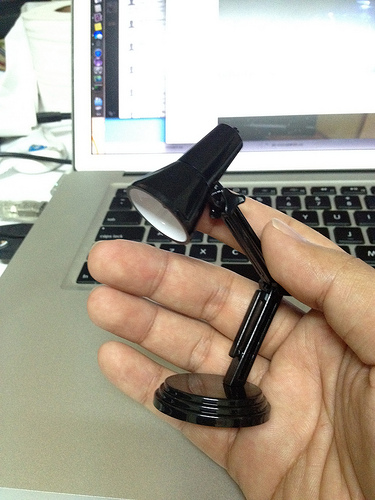<image>
Can you confirm if the lamp is on the laptop? No. The lamp is not positioned on the laptop. They may be near each other, but the lamp is not supported by or resting on top of the laptop. Where is the desk lamp in relation to the finger? Is it under the finger? Yes. The desk lamp is positioned underneath the finger, with the finger above it in the vertical space. Where is the computer screen in relation to the middle finger? Is it above the middle finger? No. The computer screen is not positioned above the middle finger. The vertical arrangement shows a different relationship. 